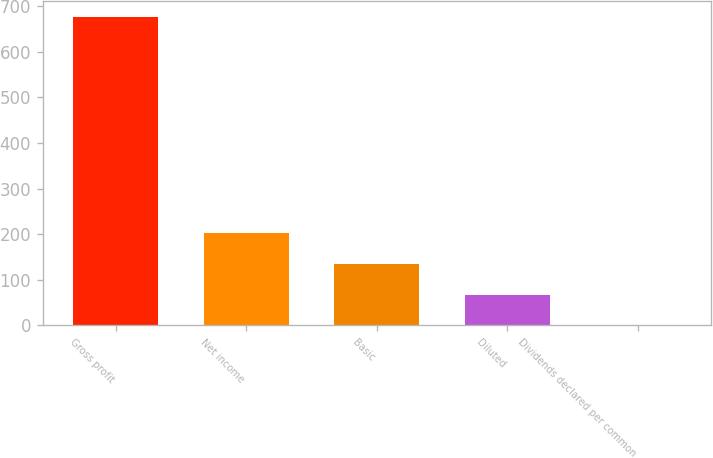Convert chart. <chart><loc_0><loc_0><loc_500><loc_500><bar_chart><fcel>Gross profit<fcel>Net income<fcel>Basic<fcel>Diluted<fcel>Dividends declared per common<nl><fcel>676.5<fcel>203<fcel>135.35<fcel>67.7<fcel>0.05<nl></chart> 